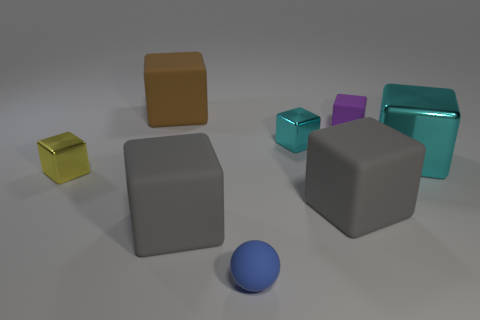Is the large cube behind the big cyan block made of the same material as the yellow cube?
Your response must be concise. No. What is the material of the yellow thing on the left side of the purple thing?
Provide a succinct answer. Metal. What size is the shiny thing that is on the right side of the tiny metallic cube that is to the right of the yellow metallic object?
Your answer should be compact. Large. Are there any other blocks that have the same material as the tiny purple block?
Provide a short and direct response. Yes. What shape is the gray matte thing that is on the right side of the tiny object that is in front of the cube on the left side of the brown rubber cube?
Make the answer very short. Cube. Is the color of the large block that is on the right side of the tiny purple rubber thing the same as the small shiny object that is to the right of the tiny yellow thing?
Your response must be concise. Yes. Are there any big brown objects in front of the small blue sphere?
Keep it short and to the point. No. How many other large objects have the same shape as the brown thing?
Provide a short and direct response. 3. There is a small block in front of the small metallic thing right of the shiny thing to the left of the large brown thing; what color is it?
Make the answer very short. Yellow. Are the small object that is in front of the yellow shiny object and the small thing left of the blue matte sphere made of the same material?
Your answer should be very brief. No. 